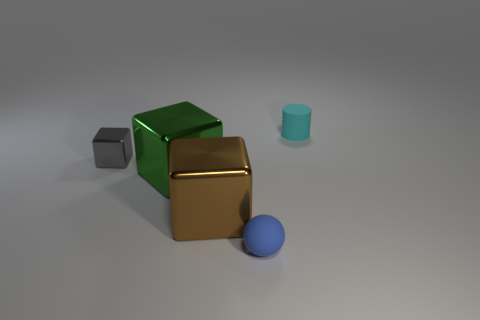Add 4 tiny purple matte cylinders. How many objects exist? 9 Subtract all spheres. How many objects are left? 4 Subtract all cyan cylinders. Subtract all brown shiny balls. How many objects are left? 4 Add 4 cylinders. How many cylinders are left? 5 Add 3 tiny rubber cylinders. How many tiny rubber cylinders exist? 4 Subtract 0 purple cylinders. How many objects are left? 5 